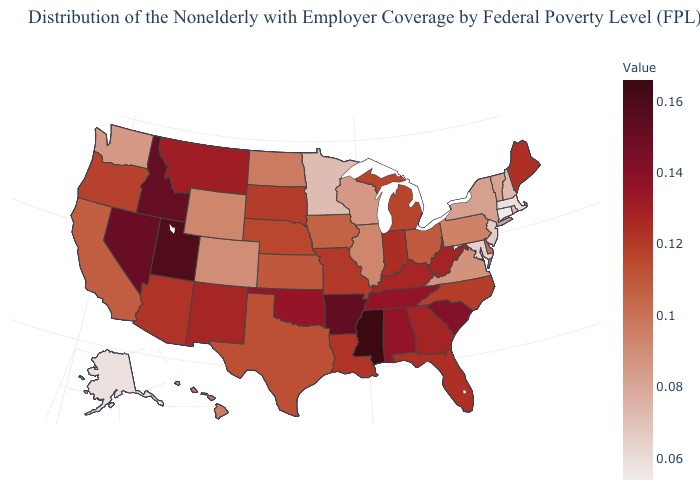Does Connecticut have the lowest value in the USA?
Give a very brief answer. Yes. Which states have the lowest value in the USA?
Write a very short answer. Connecticut. Does Illinois have a higher value than Maryland?
Quick response, please. Yes. Which states have the lowest value in the West?
Be succinct. Alaska. 